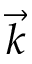<formula> <loc_0><loc_0><loc_500><loc_500>\vec { k }</formula> 